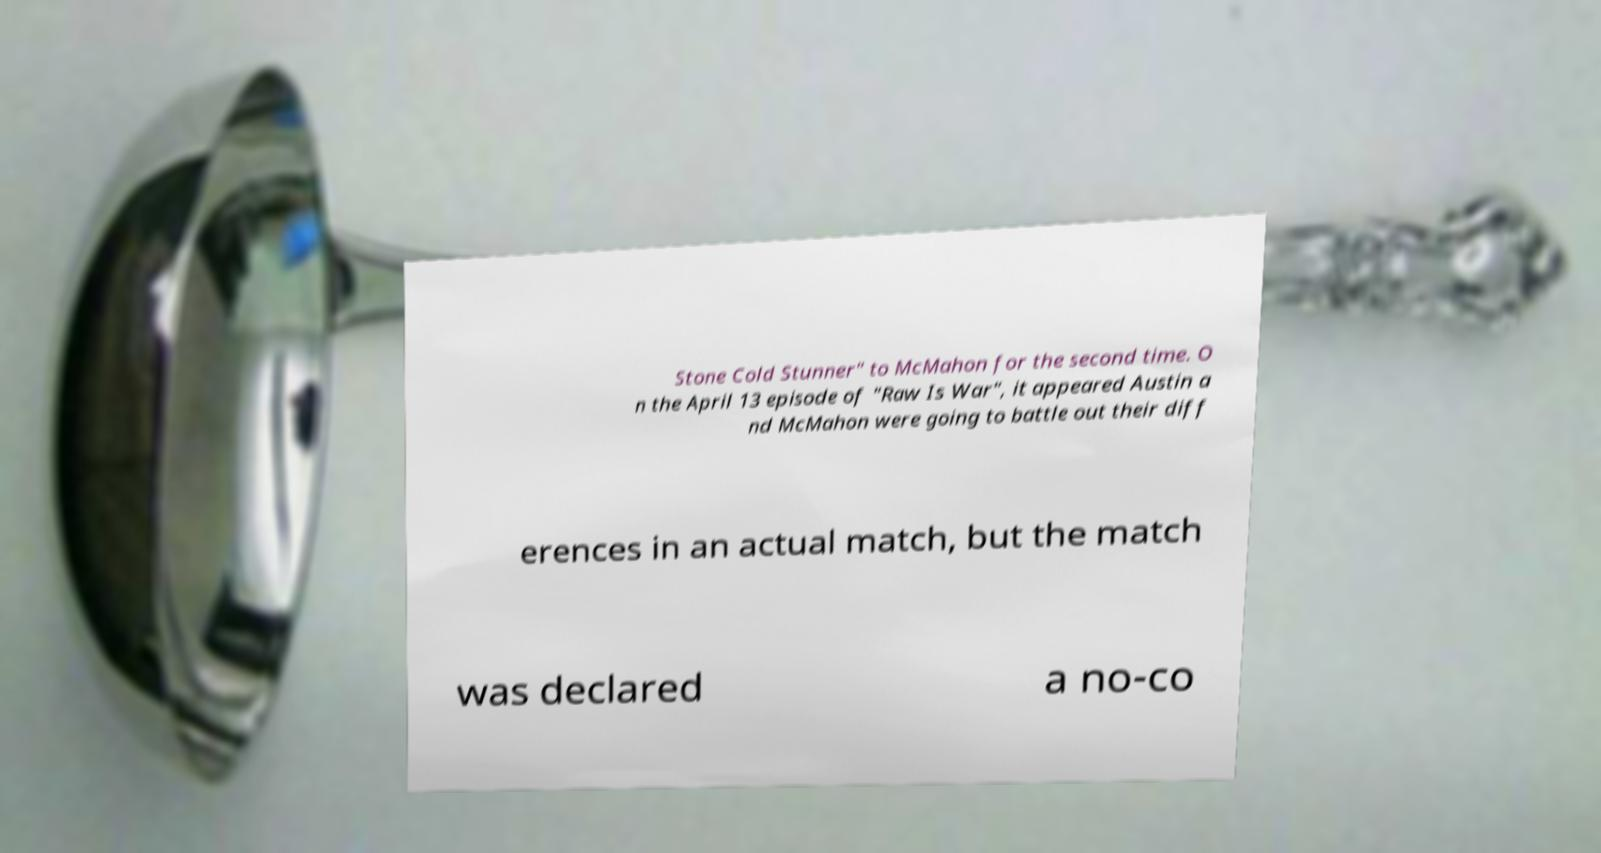There's text embedded in this image that I need extracted. Can you transcribe it verbatim? Stone Cold Stunner" to McMahon for the second time. O n the April 13 episode of "Raw Is War", it appeared Austin a nd McMahon were going to battle out their diff erences in an actual match, but the match was declared a no-co 